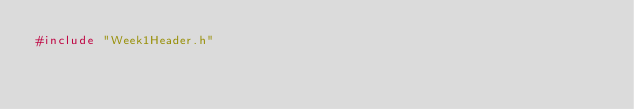<code> <loc_0><loc_0><loc_500><loc_500><_C++_>#include "Week1Header.h"
</code> 